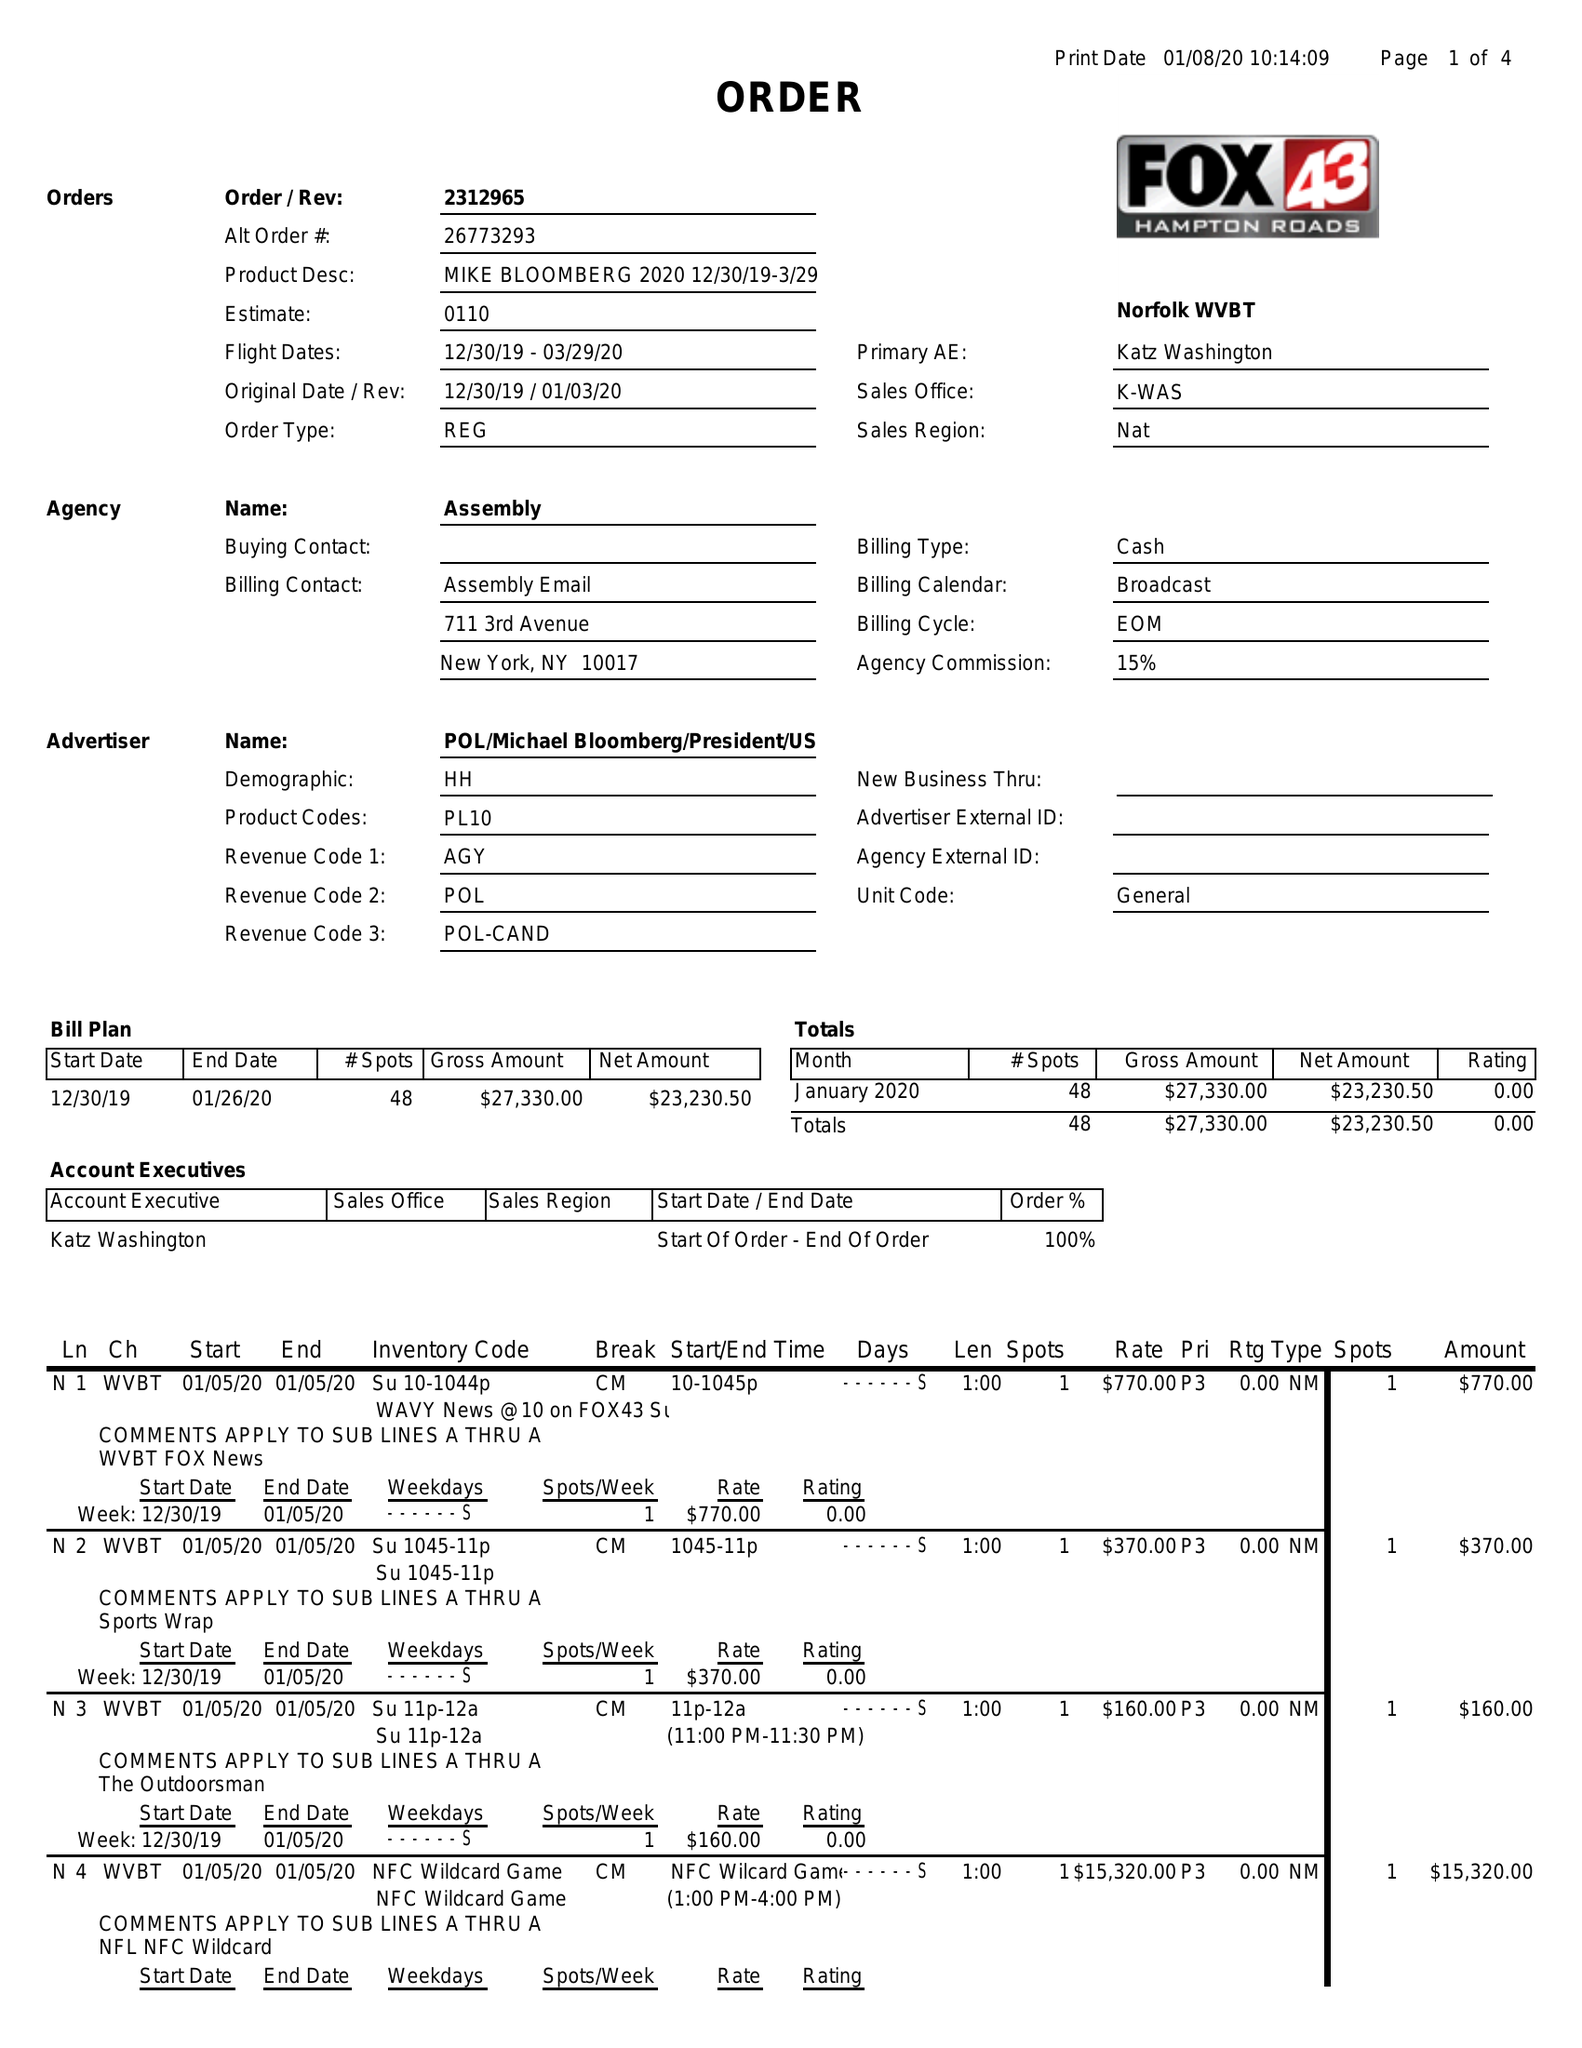What is the value for the contract_num?
Answer the question using a single word or phrase. 2312965 